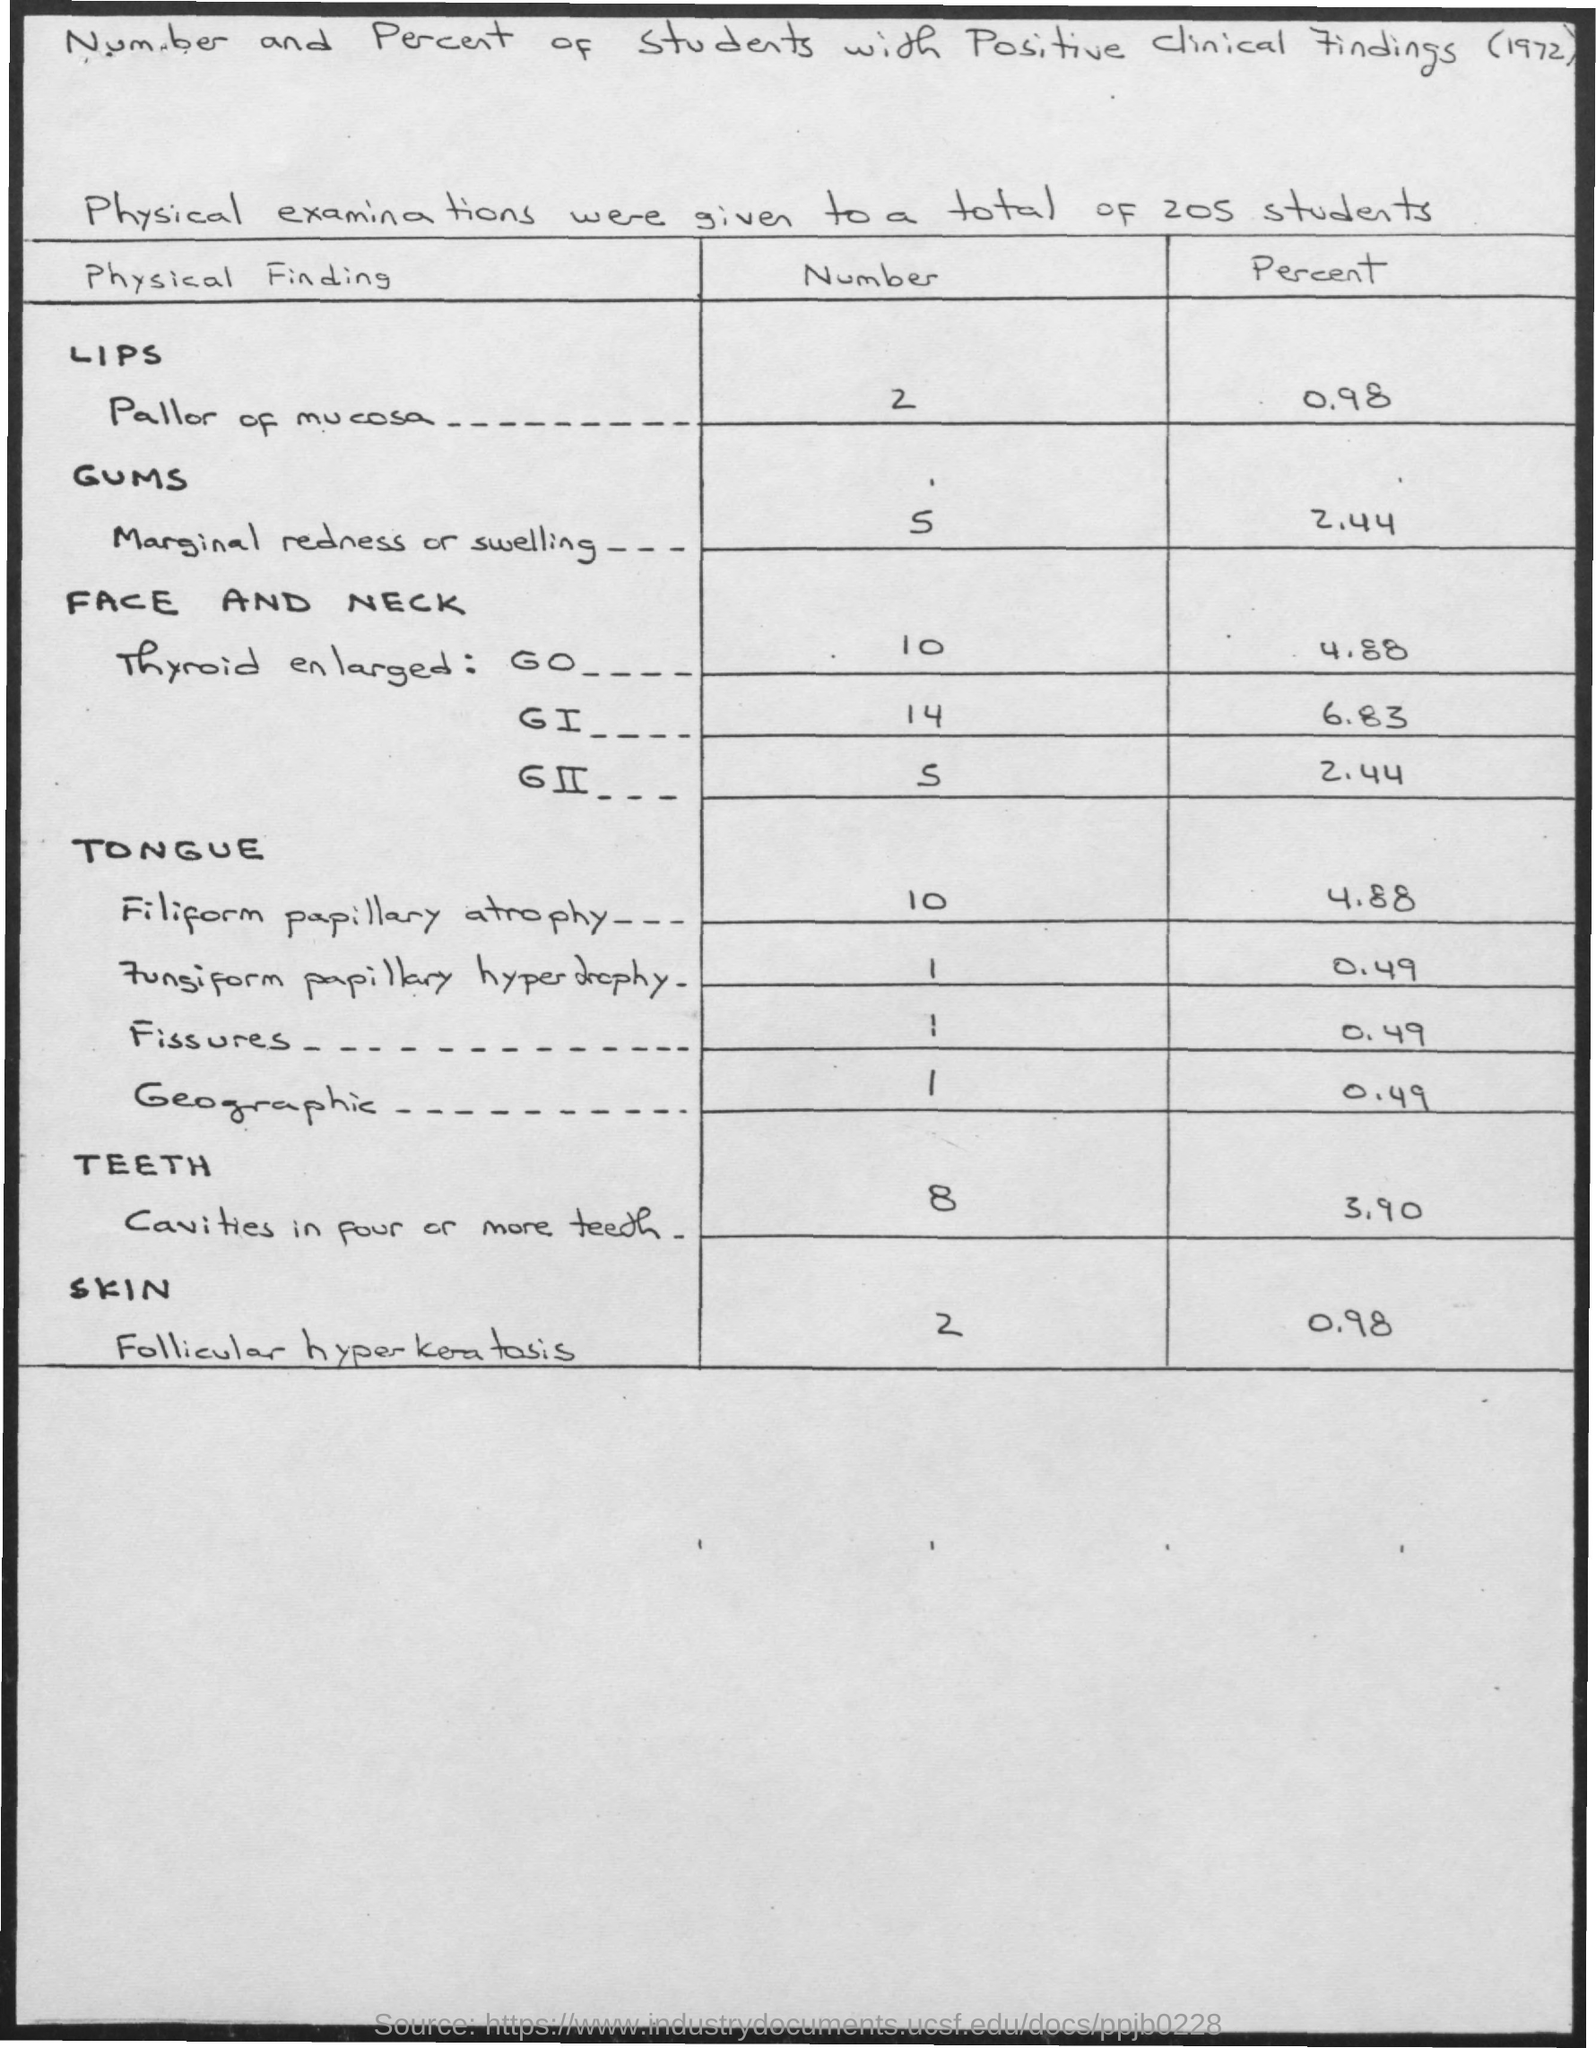To how many students were physical examinations given?
Your response must be concise. 205 students. How many of them were found with Pallor of mucosa on their lips?
Provide a short and direct response. 2. How many of them were found with marginal redness or swelling?
Provide a succinct answer. 5. How many were found with Thyroid enlarged: G0 ?
Offer a terse response. 10. How many were found with Thyroid enlarged: GI ?
Ensure brevity in your answer.  14. How many were found with Thyroid enlarged: GII ?
Make the answer very short. 5. How much percent were found with Pallor of mucosa on their lips?
Provide a short and direct response. 0.98. How much percent were found with marginal redness or swelling?
Your answer should be compact. 2.44. How much percent were found with Thyroid enlarged: G0 ?
Give a very brief answer. 4.88. How much percent were found with Thyroid enlarged: GI ?
Your answer should be very brief. 6.83. 